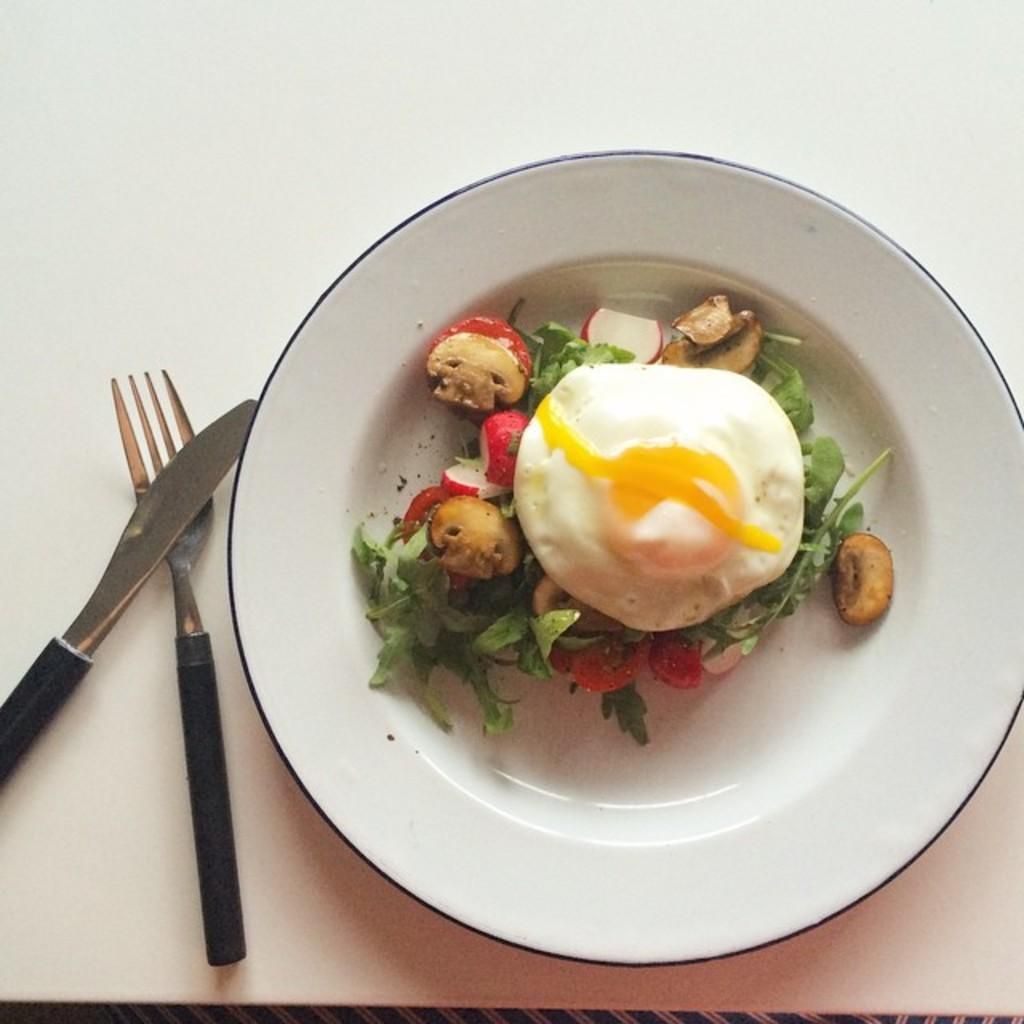What type of egg is on the plate in the image? There is a poached egg on a plate in the image. What other food item is on the plate in the image? There is a salad on the plate in the image. Where is the plate located in the image? The plate is on top of a table in the image. What utensils are beside the plate in the image? There is a fork and a knife beside the plate in the image. What effect does the ant have on the poached egg in the image? There is no ant present in the image, so it cannot have any effect on the poached egg. 